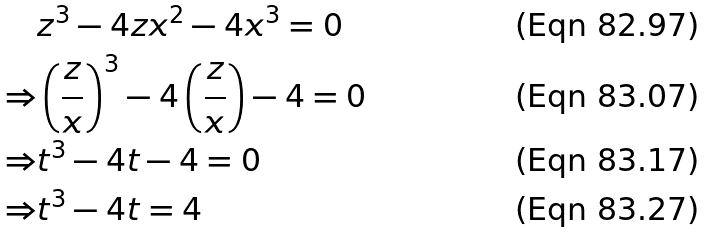<formula> <loc_0><loc_0><loc_500><loc_500>& z ^ { 3 } - 4 z x ^ { 2 } - 4 x ^ { 3 } = 0 \\ \Rightarrow & \left ( \frac { z } { x } \right ) ^ { 3 } - 4 \left ( \frac { z } { x } \right ) - 4 = 0 \\ \Rightarrow & t ^ { 3 } - 4 t - 4 = 0 \\ \Rightarrow & t ^ { 3 } - 4 t = 4</formula> 